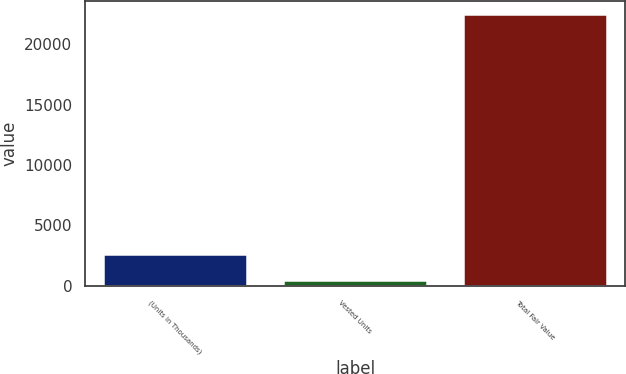Convert chart. <chart><loc_0><loc_0><loc_500><loc_500><bar_chart><fcel>(Units in Thousands)<fcel>Vested Units<fcel>Total Fair Value<nl><fcel>2666.2<fcel>467<fcel>22459<nl></chart> 